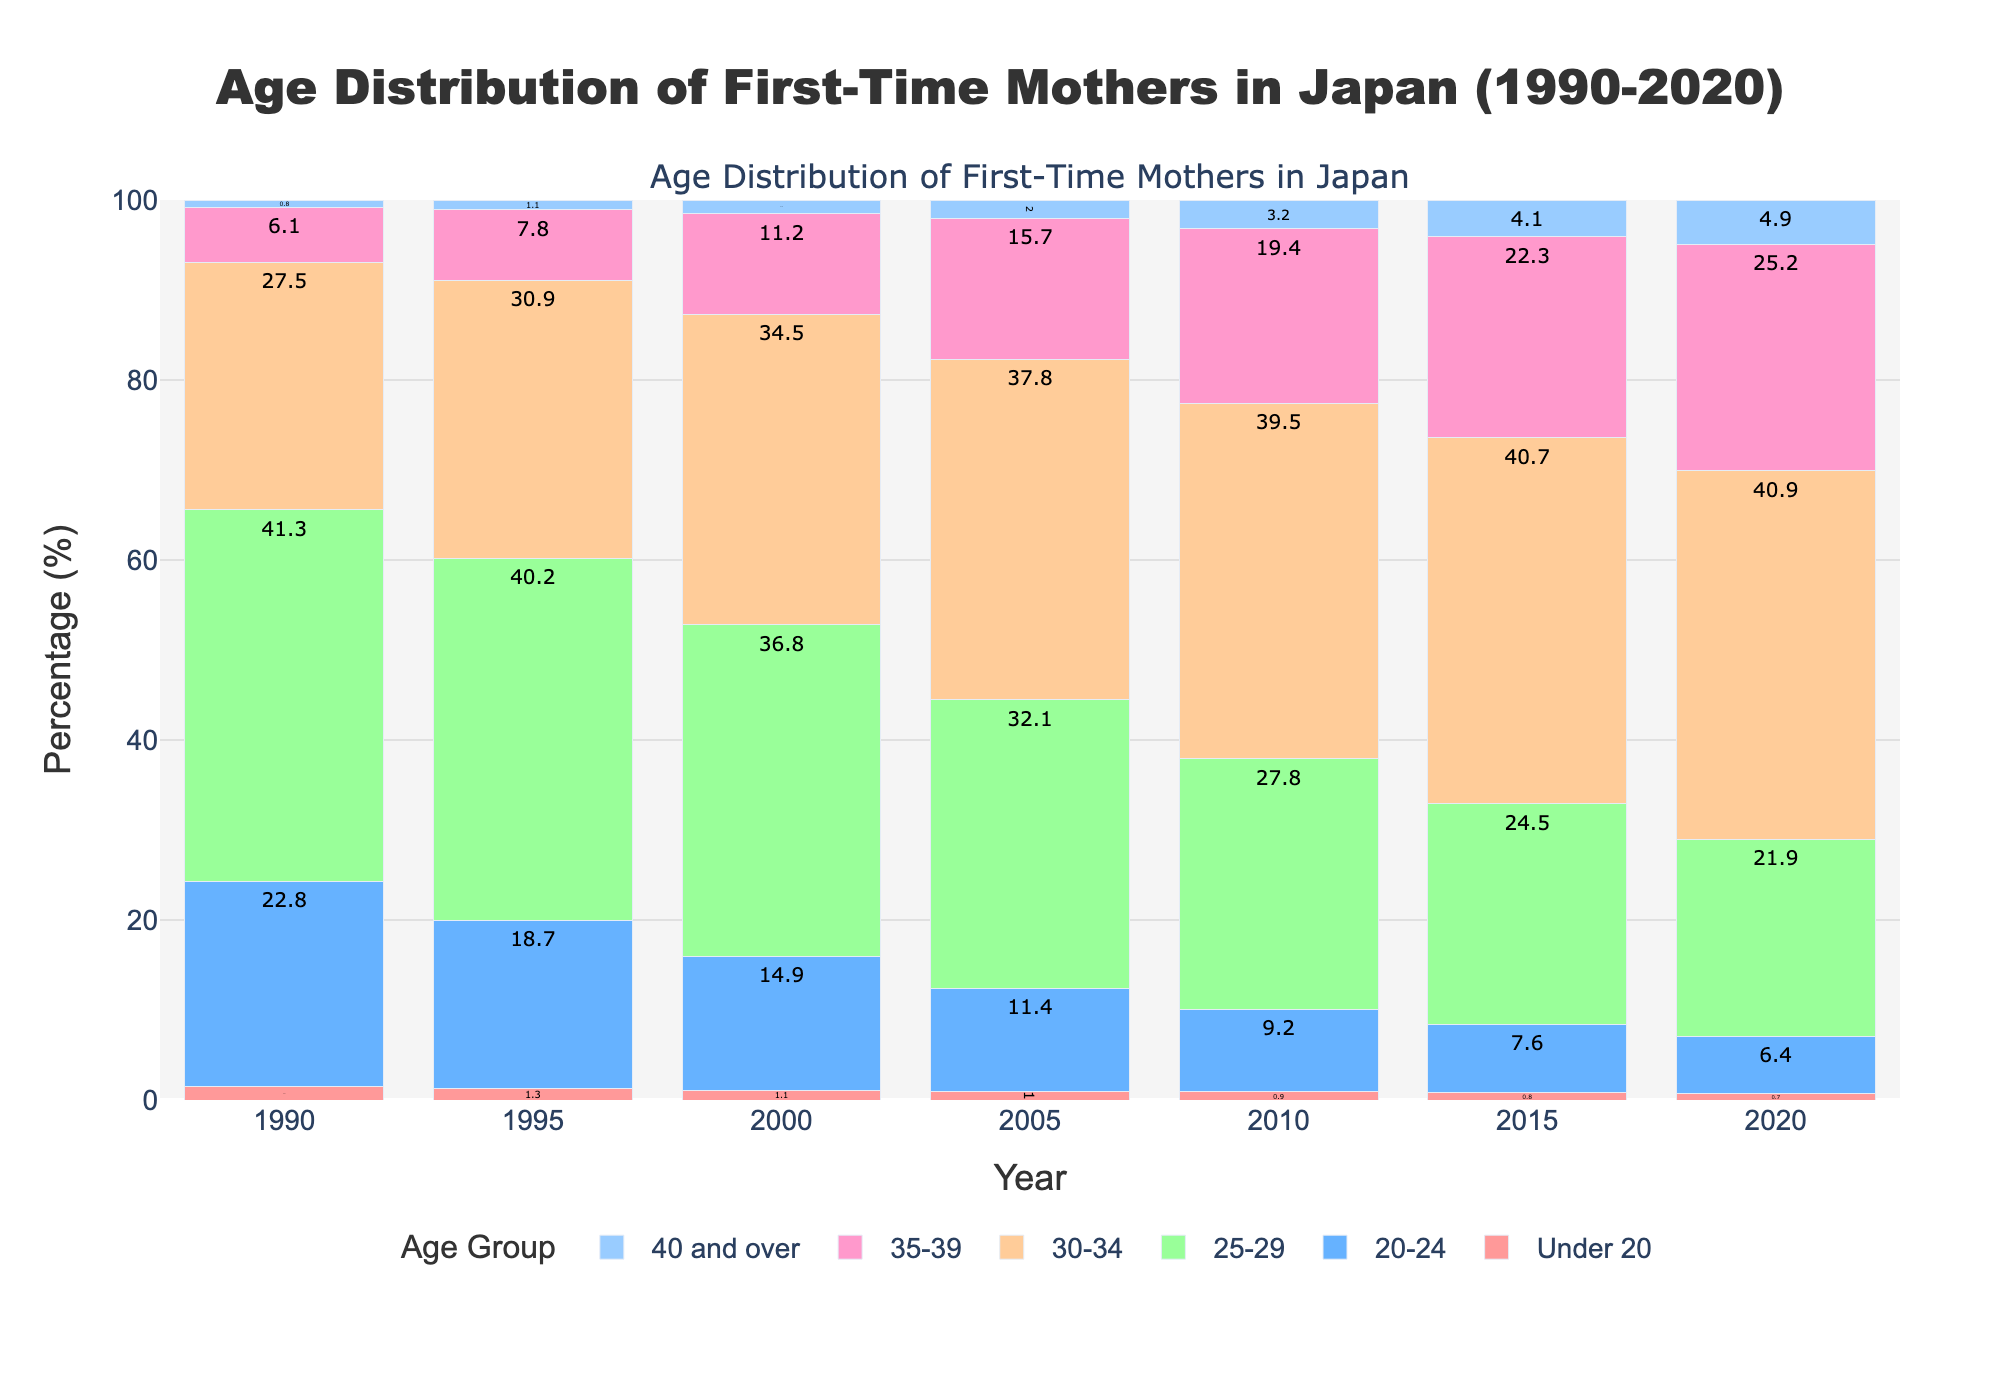How has the percentage of first-time mothers aged under 20 changed from 1990 to 2020? To find this, we look at the respective percentage values for the 'Under 20' age group in 1990 and 2020 as shown in the data. For 1990, it's 1.5%, and for 2020, it's 0.7%. Thus, the percentage has decreased.
Answer: Decreased In which year did the 30-34 age group surpass the 25-29 age group in percentage for the first time? From a glance at the data, we compare the percentages of the '30-34' and '25-29' age groups each year. The shift occurs in 2000, where the 30-34 group (34.5%) surpasses the 25-29 group (36.8% for 25-29). This observation is based on the data trend.
Answer: 2000 Which age group had the most significant increase in the percentage of first-time mothers from 1990 to 2020? To determine this, we calculate the difference in percentages between 1990 and 2020 for each age group. The '35-39' age group increased from 6.1% in 1990 to 25.2% in 2020, representing a substantial increase.
Answer: 35-39 How did the share of first-time mothers in the 20-24 age group change from 1990 to 2020? By checking the '20-24' age group's percentages for 1990 and 2020, we see they decreased from 22.8% in 1990 to 6.4% in 2020. This indicates that the share has significantly decreased over the years.
Answer: Decreased What is the total percentage of first-time mothers aged 30 and over in 2010? To find this, we sum the percentages of the age groups '30-34', '35-39', and '40 and over' for the year 2010: 39.5% + 19.4% + 3.2% = 62.1%.
Answer: 62.1% Which age group has shown a consistent increase every 5 years from 1990 to 2020? By examining the data for each age group across the given years, the '35-39' age group shows a consistent increase: 6.1% (1990), 7.8% (1995), 11.2% (2000), 15.7% (2005), 19.4% (2010), 22.3% (2015), 25.2% (2020). This indicates a steady increase over the years.
Answer: 35-39 Compare the percentage share of first-time mothers aged 40 and over in 1990 and 2020. How much has it increased by? Look at the values for the '40 and over' age group in 1990 and 2020: 0.8% in 1990 and 4.9% in 2020. The increase is 4.9% - 0.8% = 4.1%.
Answer: 4.1% In which year did the age group 25-29 have the highest percentage share of first-time mothers? From the data, we look at the percentages for the '25-29' age group across the years and identify the highest percentage. It is in 1990 with 41.3%.
Answer: 1990 Is there a significant difference in the percentage of first-time mothers aged 30-34 between 1990 and 2020? Checking the values for '30-34' group in 1990 (27.5%) and 2020 (40.9%) shows an increase. The difference is substantial: 40.9% - 27.5% = 13.4%.
Answer: Yes, 13.4% increase 